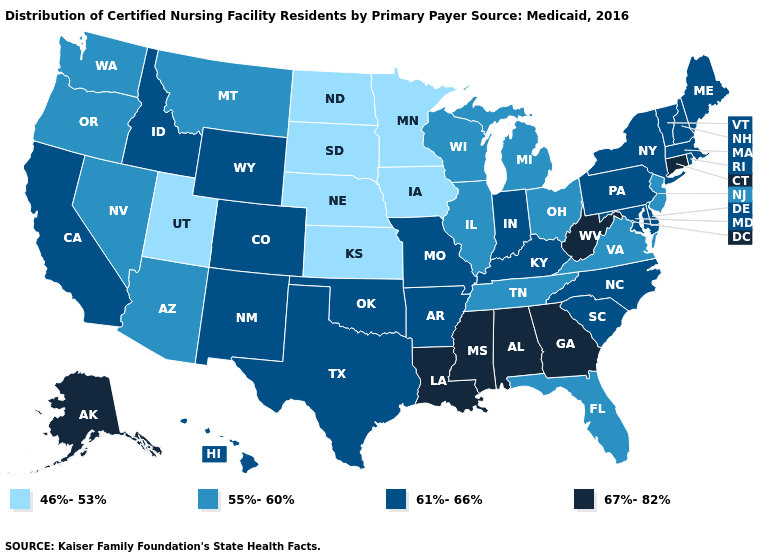What is the value of Washington?
Concise answer only. 55%-60%. How many symbols are there in the legend?
Short answer required. 4. Does the first symbol in the legend represent the smallest category?
Answer briefly. Yes. Does Arizona have a higher value than Maine?
Keep it brief. No. Name the states that have a value in the range 55%-60%?
Quick response, please. Arizona, Florida, Illinois, Michigan, Montana, Nevada, New Jersey, Ohio, Oregon, Tennessee, Virginia, Washington, Wisconsin. What is the highest value in the USA?
Answer briefly. 67%-82%. How many symbols are there in the legend?
Give a very brief answer. 4. What is the value of Illinois?
Answer briefly. 55%-60%. Does Tennessee have the lowest value in the South?
Be succinct. Yes. Which states have the highest value in the USA?
Give a very brief answer. Alabama, Alaska, Connecticut, Georgia, Louisiana, Mississippi, West Virginia. What is the value of Missouri?
Quick response, please. 61%-66%. Which states have the lowest value in the USA?
Answer briefly. Iowa, Kansas, Minnesota, Nebraska, North Dakota, South Dakota, Utah. Name the states that have a value in the range 55%-60%?
Short answer required. Arizona, Florida, Illinois, Michigan, Montana, Nevada, New Jersey, Ohio, Oregon, Tennessee, Virginia, Washington, Wisconsin. Among the states that border Vermont , which have the lowest value?
Answer briefly. Massachusetts, New Hampshire, New York. What is the value of Oregon?
Write a very short answer. 55%-60%. 